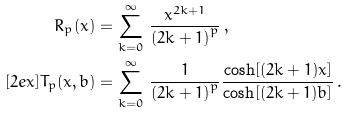<formula> <loc_0><loc_0><loc_500><loc_500>R _ { p } ( x ) = & \, \sum _ { k = 0 } ^ { \infty } \, \frac { x ^ { 2 k + 1 } } { { ( 2 k + 1 ) } ^ { p } } \, , \\ [ 2 e x ] T _ { p } ( x , b ) = & \, \sum _ { k = 0 } ^ { \infty } \, \frac { 1 } { { ( 2 k + 1 ) } ^ { p } } \frac { \cosh [ ( 2 k + 1 ) x ] } { \cosh [ ( 2 k + 1 ) b ] } \, .</formula> 